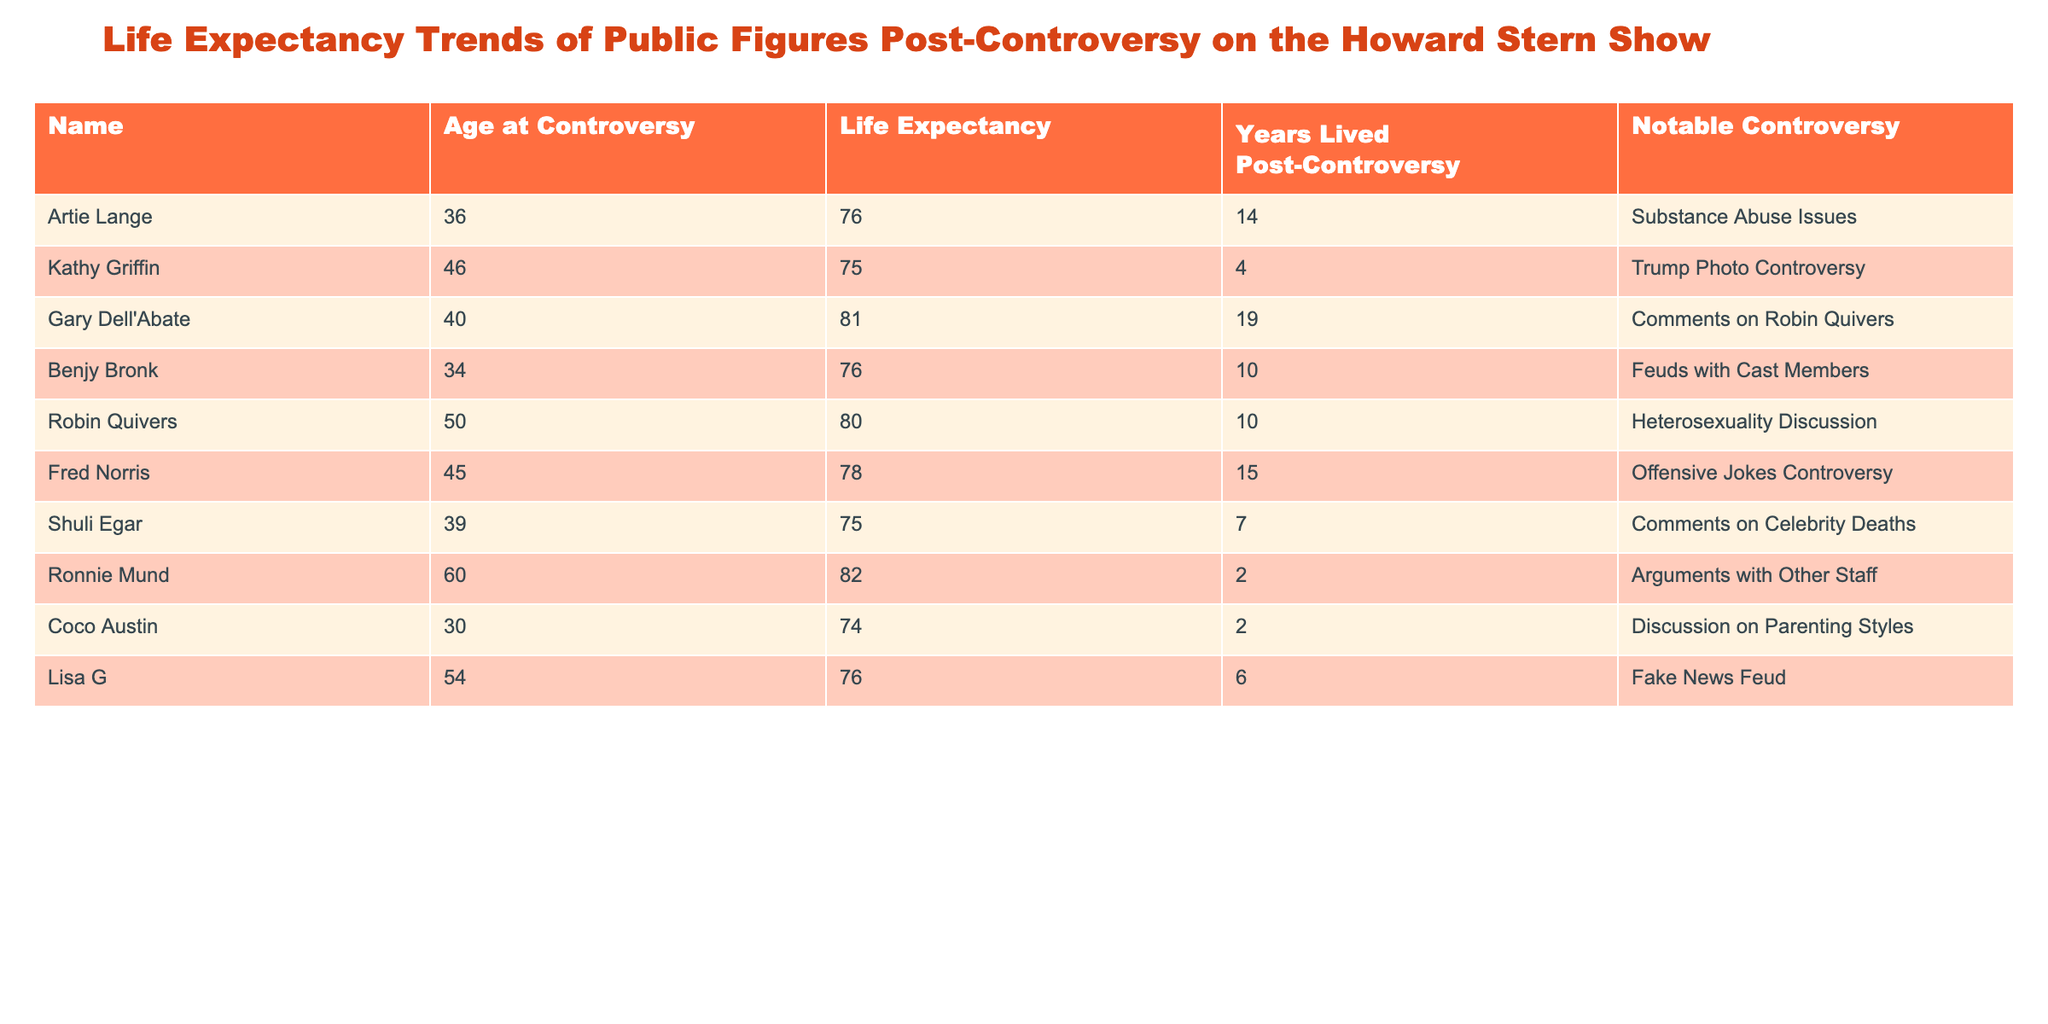What was the age of Robin Quivers at the time of her notable controversy? Looking at the table, Robin Quivers is listed with an age at controversy of 50.
Answer: 50 Which public figure had the longest life expectancy post-controversy, and what is that expectancy? By examining the table, Ronnie Mund has the highest life expectancy of 82 years post-controversy.
Answer: 82 How many years did Artie Lange live post-controversy? The table indicates that Artie Lange lived for 14 years after his controversy.
Answer: 14 Is it true that Kathy Griffin had a longer life expectancy than Shuli Egar? Considering the life expectancy data, Kathy Griffin has a life expectancy of 75 years, while Shuli Egar has a life expectancy of 75 years too, making it false that Kathy had a longer expectancy.
Answer: No What is the average life expectancy among all public figures listed in the table? To find the average life expectancy, we add up all the life expectancies: 76 + 75 + 81 + 76 + 80 + 78 + 75 + 82 + 74 + 76 =  76.5. There are 10 figures, so the average is 765/10 = 76.5.
Answer: 76.5 Which public figure had a controversy related to offensive jokes, and what was their life expectancy? The table shows that Fred Norris had a controversy due to offensive jokes, and his life expectancy is listed as 78 years.
Answer: Fred Norris, 78 Did any of the public figures live less than five years after their controversy? Looking at the table, both Ronnie Mund and Coco Austin lived only 2 years post-controversy, confirming that this is true.
Answer: Yes How many public figures had a life expectancy lower than 75 years? From the table, both Kathy Griffin and Coco Austin had life expectancies of 75 and 74 years respectively. Thus, only Coco has a life expectancy below 75.
Answer: 1 